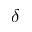<formula> <loc_0><loc_0><loc_500><loc_500>\delta</formula> 